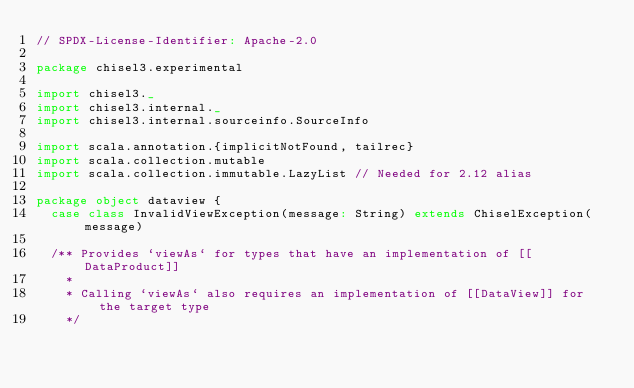Convert code to text. <code><loc_0><loc_0><loc_500><loc_500><_Scala_>// SPDX-License-Identifier: Apache-2.0

package chisel3.experimental

import chisel3._
import chisel3.internal._
import chisel3.internal.sourceinfo.SourceInfo

import scala.annotation.{implicitNotFound, tailrec}
import scala.collection.mutable
import scala.collection.immutable.LazyList // Needed for 2.12 alias

package object dataview {
  case class InvalidViewException(message: String) extends ChiselException(message)

  /** Provides `viewAs` for types that have an implementation of [[DataProduct]]
    *
    * Calling `viewAs` also requires an implementation of [[DataView]] for the target type
    */</code> 